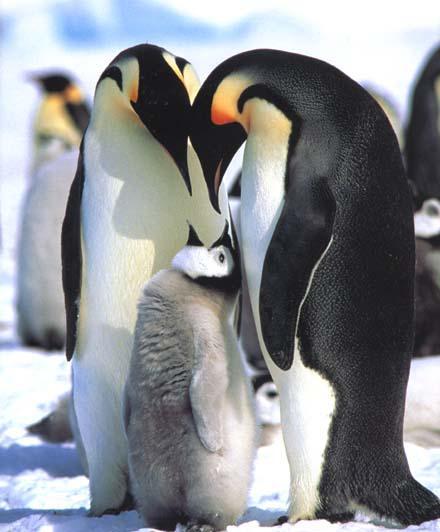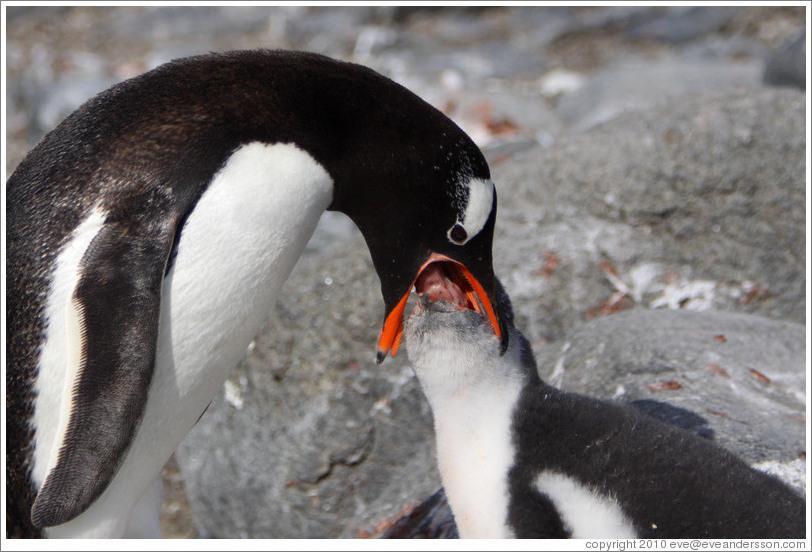The first image is the image on the left, the second image is the image on the right. For the images displayed, is the sentence "One penguin is pushing a closed beak against the back of another penguin's head." factually correct? Answer yes or no. No. The first image is the image on the left, the second image is the image on the right. Analyze the images presented: Is the assertion "One penguin nuzzles another penguin in the back of the head." valid? Answer yes or no. No. 